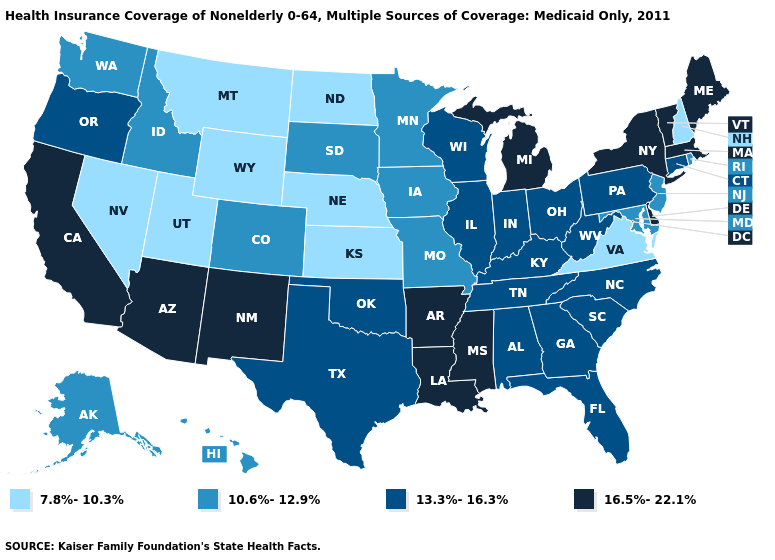Which states have the lowest value in the USA?
Be succinct. Kansas, Montana, Nebraska, Nevada, New Hampshire, North Dakota, Utah, Virginia, Wyoming. What is the lowest value in the West?
Concise answer only. 7.8%-10.3%. Name the states that have a value in the range 10.6%-12.9%?
Concise answer only. Alaska, Colorado, Hawaii, Idaho, Iowa, Maryland, Minnesota, Missouri, New Jersey, Rhode Island, South Dakota, Washington. How many symbols are there in the legend?
Answer briefly. 4. What is the highest value in the MidWest ?
Be succinct. 16.5%-22.1%. Which states hav the highest value in the West?
Quick response, please. Arizona, California, New Mexico. What is the lowest value in the USA?
Be succinct. 7.8%-10.3%. Name the states that have a value in the range 10.6%-12.9%?
Quick response, please. Alaska, Colorado, Hawaii, Idaho, Iowa, Maryland, Minnesota, Missouri, New Jersey, Rhode Island, South Dakota, Washington. Does Oklahoma have the lowest value in the South?
Short answer required. No. What is the value of Alabama?
Concise answer only. 13.3%-16.3%. Among the states that border Illinois , does Missouri have the lowest value?
Concise answer only. Yes. Name the states that have a value in the range 7.8%-10.3%?
Concise answer only. Kansas, Montana, Nebraska, Nevada, New Hampshire, North Dakota, Utah, Virginia, Wyoming. What is the highest value in the Northeast ?
Quick response, please. 16.5%-22.1%. What is the lowest value in the South?
Be succinct. 7.8%-10.3%. 